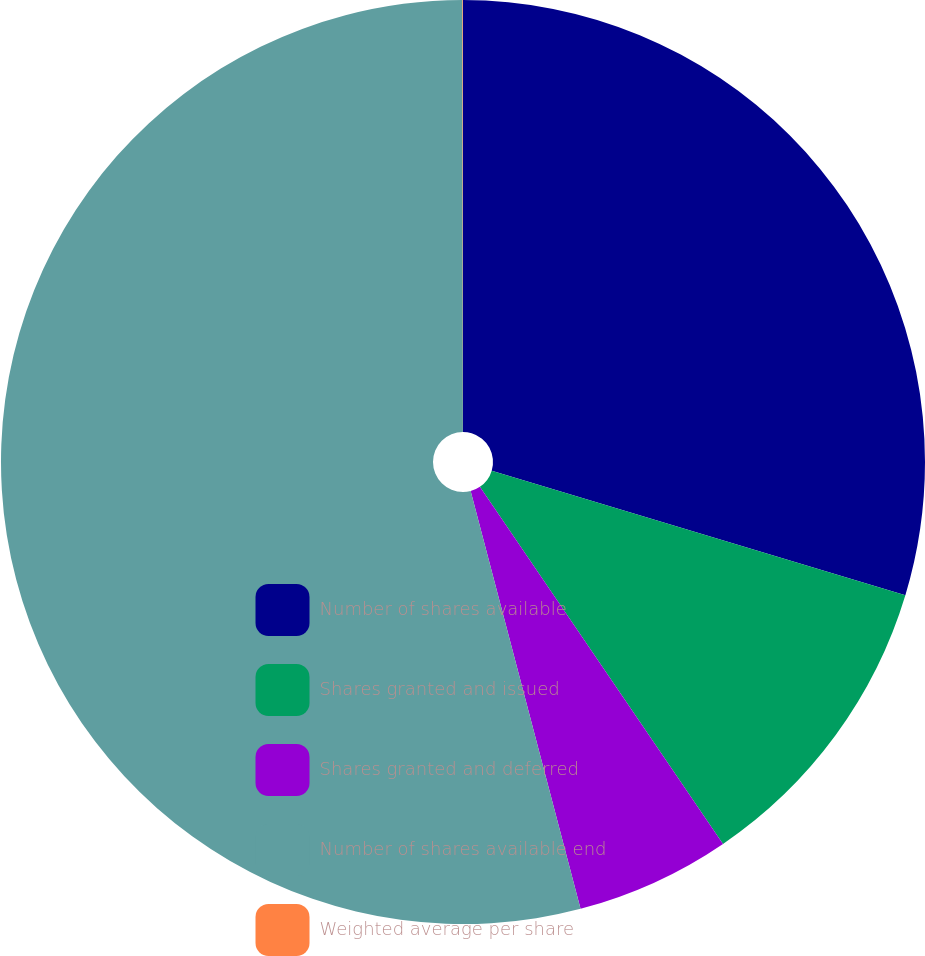<chart> <loc_0><loc_0><loc_500><loc_500><pie_chart><fcel>Number of shares available<fcel>Shares granted and issued<fcel>Shares granted and deferred<fcel>Number of shares available end<fcel>Weighted average per share<nl><fcel>29.66%<fcel>10.83%<fcel>5.42%<fcel>54.08%<fcel>0.02%<nl></chart> 